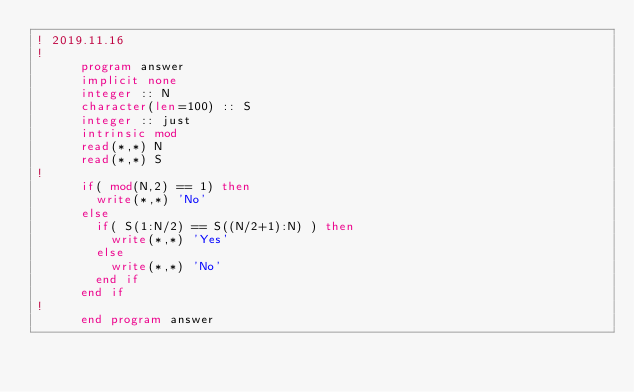<code> <loc_0><loc_0><loc_500><loc_500><_FORTRAN_>! 2019.11.16
!
      program answer
      implicit none
      integer :: N
      character(len=100) :: S
      integer :: just
      intrinsic mod
      read(*,*) N
      read(*,*) S
!
      if( mod(N,2) == 1) then
        write(*,*) 'No'
      else
        if( S(1:N/2) == S((N/2+1):N) ) then
          write(*,*) 'Yes'
        else
          write(*,*) 'No'
        end if
      end if
!
      end program answer</code> 